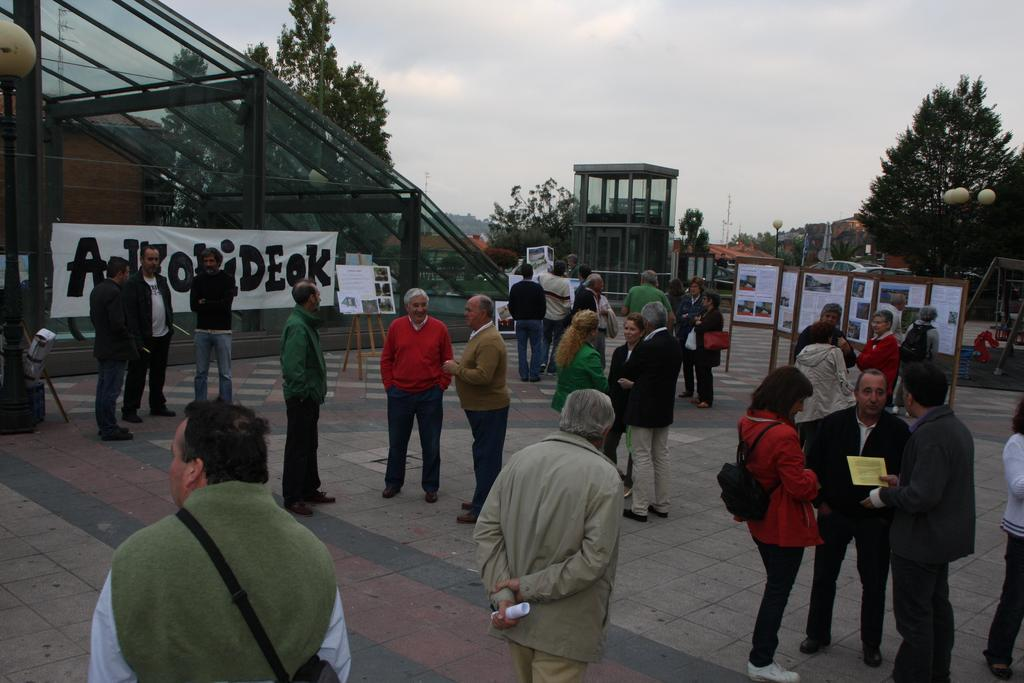What can be seen in the image? There are persons standing in the image. What type of natural environment is visible in the image? There are trees visible in the image. What is the condition of the sky in the image? Clouds are present in the sky in the image. Can you tell me how many accounts the tramp has in the image? There is no tramp or mention of accounts in the image; it features persons standing and trees visible in the natural environment. 